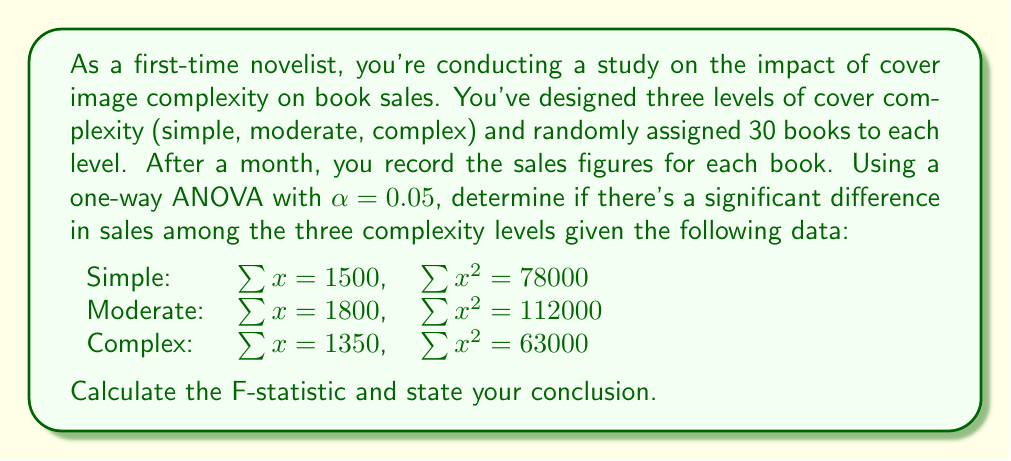Teach me how to tackle this problem. Let's approach this step-by-step:

1) First, calculate the total sum of squares (SST):
   $$SST = \sum{x^2} - \frac{(\sum{x})^2}{N}$$
   $$SST = (78000 + 112000 + 63000) - \frac{(1500 + 1800 + 1350)^2}{90}$$
   $$SST = 253000 - \frac{(4650)^2}{90} = 253000 - 240250 = 12750$$

2) Calculate the sum of squares between groups (SSB):
   $$SSB = \sum{\frac{(\sum{x_i})^2}{n_i}} - \frac{(\sum{x})^2}{N}$$
   $$SSB = \frac{1500^2}{30} + \frac{1800^2}{30} + \frac{1350^2}{30} - \frac{4650^2}{90}$$
   $$SSB = 75000 + 108000 + 60750 - 240250 = 3500$$

3) Calculate the sum of squares within groups (SSW):
   $$SSW = SST - SSB = 12750 - 3500 = 9250$$

4) Degrees of freedom:
   Between groups: $df_B = k - 1 = 3 - 1 = 2$
   Within groups: $df_W = N - k = 90 - 3 = 87$
   Total: $df_T = N - 1 = 90 - 1 = 89$

5) Mean squares:
   $$MS_B = \frac{SSB}{df_B} = \frac{3500}{2} = 1750$$
   $$MS_W = \frac{SSW}{df_W} = \frac{9250}{87} \approx 106.32$$

6) F-statistic:
   $$F = \frac{MS_B}{MS_W} = \frac{1750}{106.32} \approx 16.46$$

7) The critical F-value for $\alpha = 0.05$, $df_B = 2$, and $df_W = 87$ is approximately 3.10.

Since the calculated F-statistic (16.46) is greater than the critical F-value (3.10), we reject the null hypothesis.
Answer: The F-statistic is approximately 16.46. Since this value is greater than the critical F-value of 3.10, we conclude that there is a significant difference in sales among the three cover complexity levels at the 0.05 significance level. 